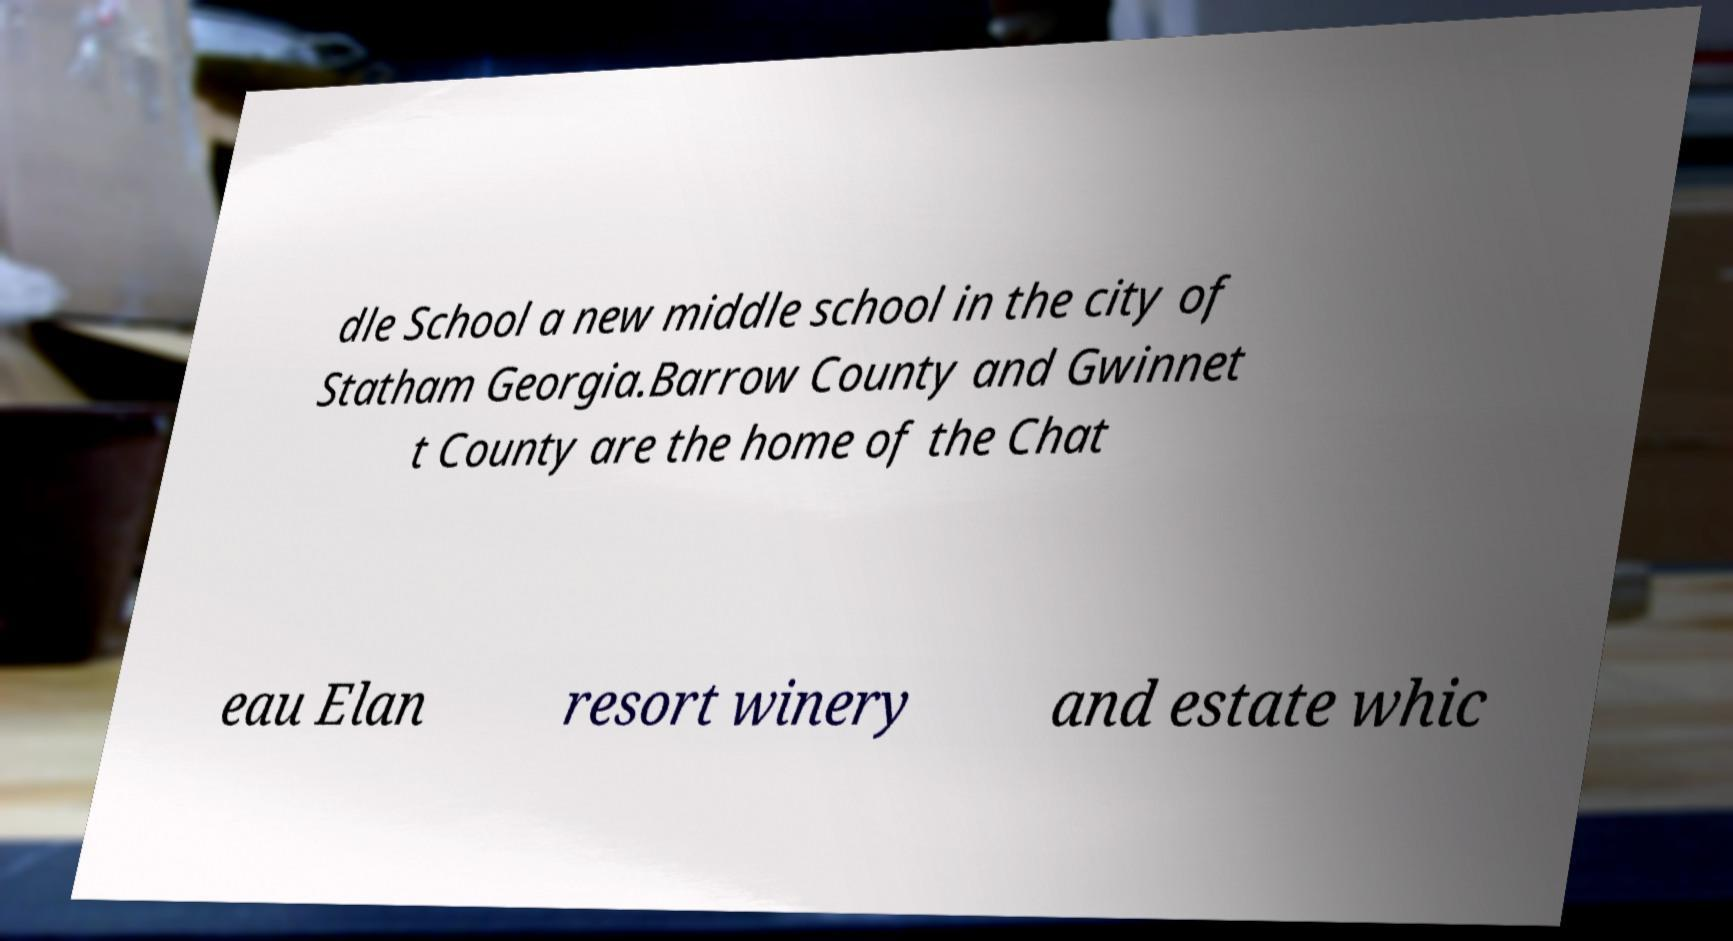There's text embedded in this image that I need extracted. Can you transcribe it verbatim? dle School a new middle school in the city of Statham Georgia.Barrow County and Gwinnet t County are the home of the Chat eau Elan resort winery and estate whic 